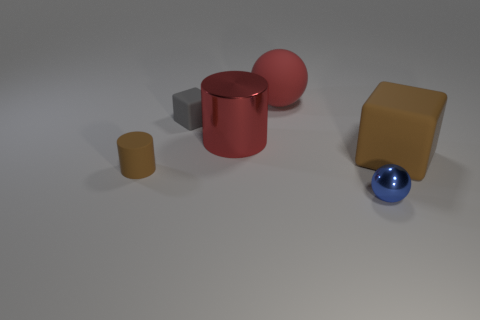Add 3 red matte balls. How many objects exist? 9 Subtract all spheres. How many objects are left? 4 Subtract 1 balls. How many balls are left? 1 Subtract all purple balls. Subtract all yellow cylinders. How many balls are left? 2 Subtract all purple cylinders. How many red spheres are left? 1 Subtract all blue rubber objects. Subtract all big red cylinders. How many objects are left? 5 Add 2 red matte objects. How many red matte objects are left? 3 Add 3 matte cylinders. How many matte cylinders exist? 4 Subtract 0 red blocks. How many objects are left? 6 